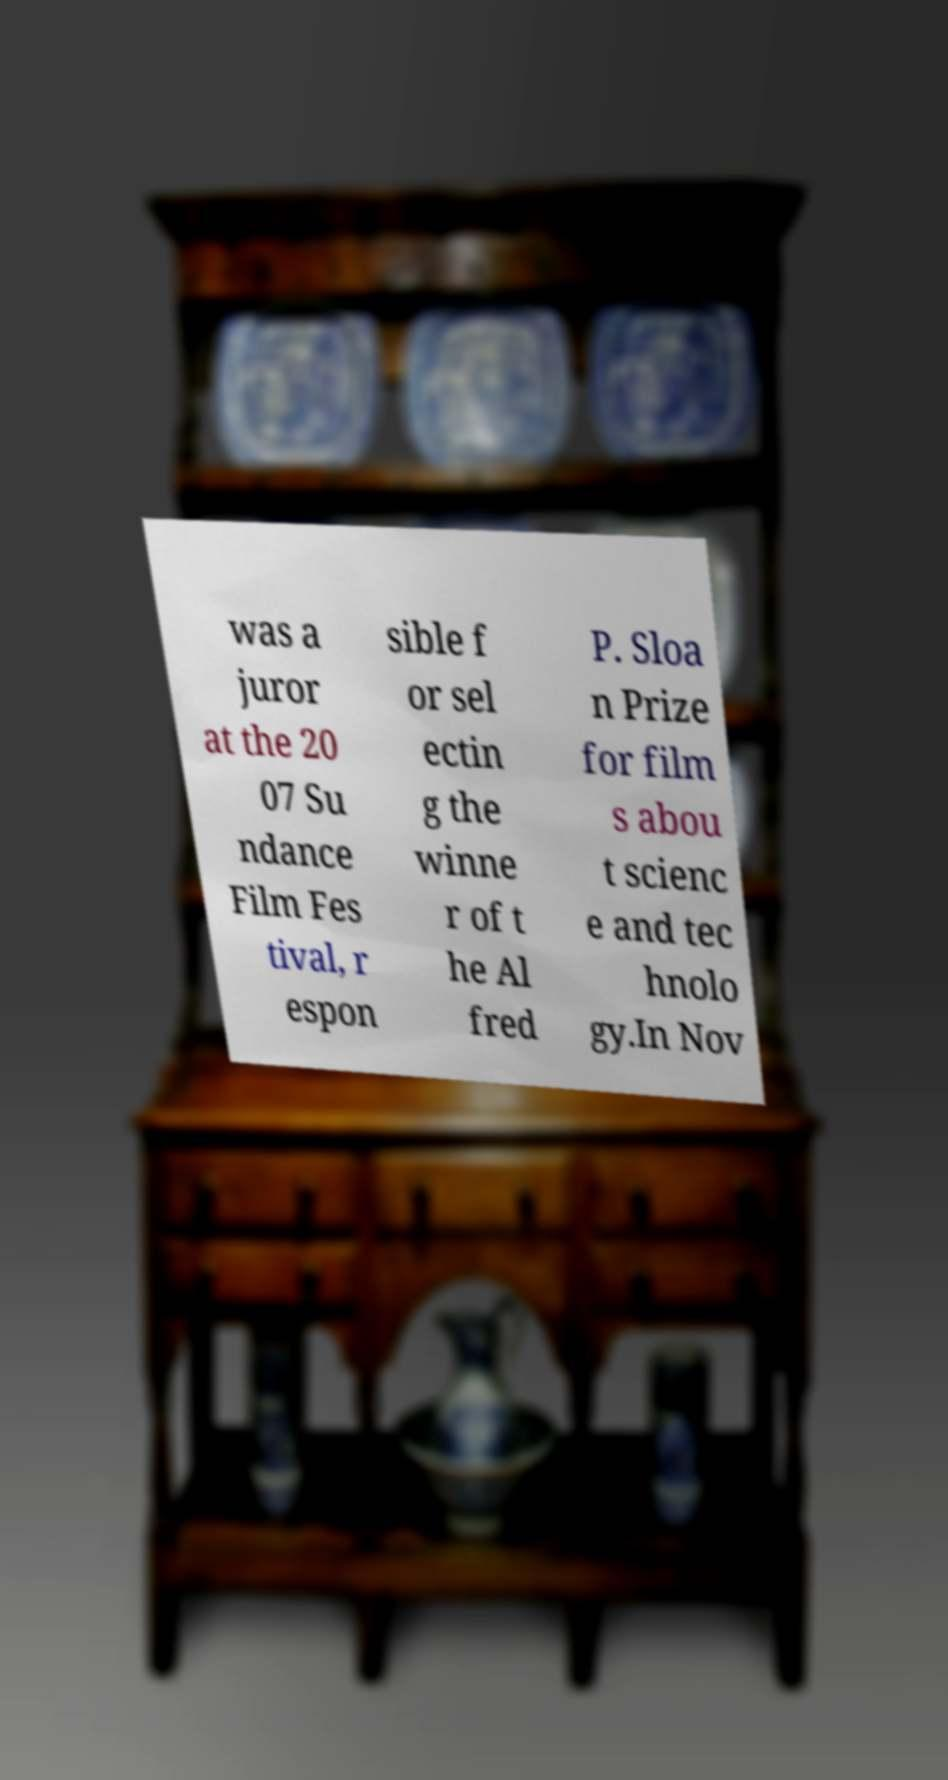Could you extract and type out the text from this image? was a juror at the 20 07 Su ndance Film Fes tival, r espon sible f or sel ectin g the winne r of t he Al fred P. Sloa n Prize for film s abou t scienc e and tec hnolo gy.In Nov 